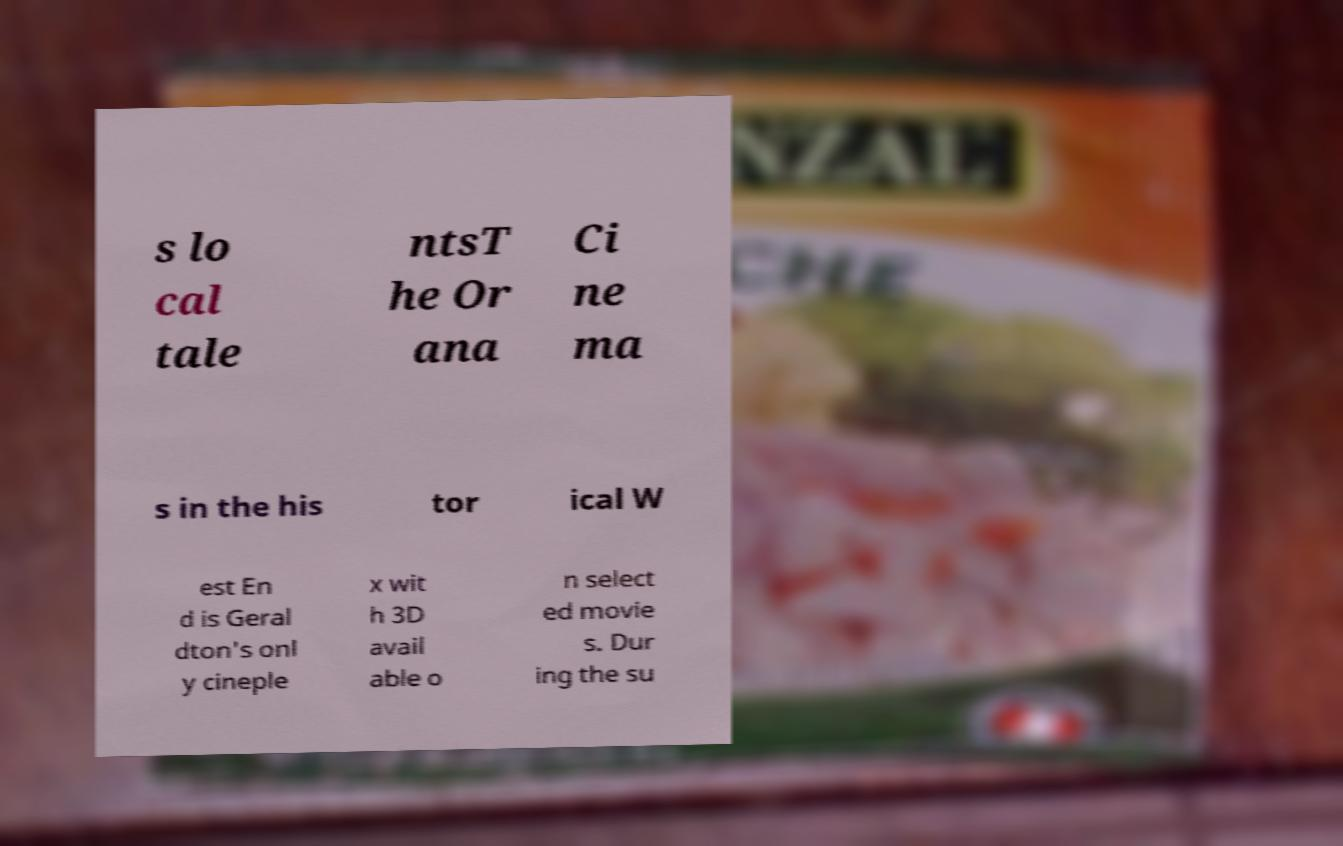Please read and relay the text visible in this image. What does it say? s lo cal tale ntsT he Or ana Ci ne ma s in the his tor ical W est En d is Geral dton's onl y cineple x wit h 3D avail able o n select ed movie s. Dur ing the su 